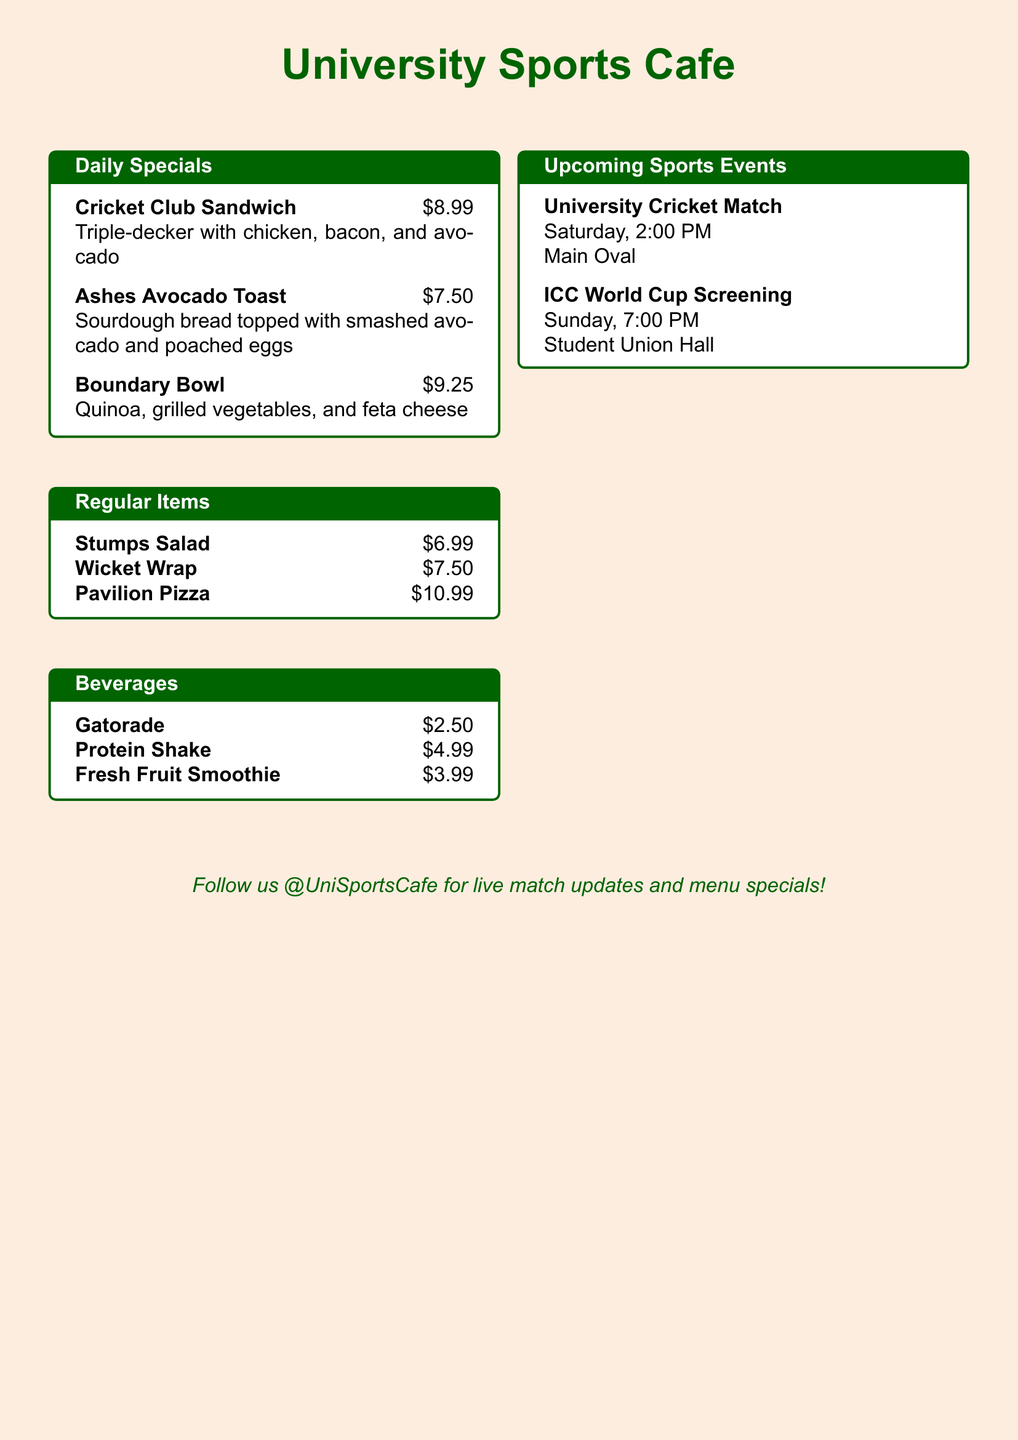What is the name of the special sandwich? The document lists the "Cricket Club Sandwich" as a daily special, making it the name of the special sandwich.
Answer: Cricket Club Sandwich How much does the Boundary Bowl cost? The cost of the Boundary Bowl is specified in the document, which is $9.25.
Answer: $9.25 What beverage is priced at $2.50? The document states that "Gatorade" is the beverage priced at $2.50.
Answer: Gatorade When is the University Cricket Match scheduled? The schedule for the University Cricket Match is mentioned in the document as Saturday at 2:00 PM.
Answer: Saturday, 2:00 PM What is a regular item listed on the menu? The document lists several regular items, one of which is "Stumps Salad."
Answer: Stumps Salad What is the venue for the ICC World Cup Screening? The document indicates that the ICC World Cup Screening will take place at the "Student Union Hall."
Answer: Student Union Hall What is the main color theme of the University Sports Cafe? The dominant color theme throughout the document is "cricket green," as reflected in the headers and boxes.
Answer: cricket green How many daily specials are listed? There are three daily specials mentioned in the document.
Answer: Three What dessert item is included in the menu? The menu does not list any dessert items specifically mentioned, making it clear that none are included.
Answer: None 